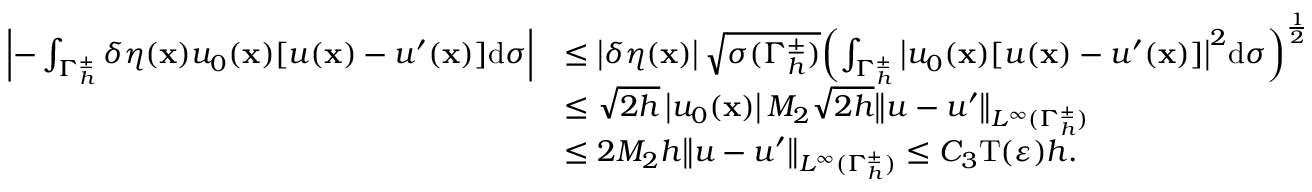<formula> <loc_0><loc_0><loc_500><loc_500>\begin{array} { r l } { \left | - \int _ { { \Gamma _ { h } ^ { \pm } } } \delta \eta ( \mathbf x ) { { u _ { 0 } } ( \mathbf x ) [ u ( \mathbf x ) - u ^ { \prime } ( \mathbf x ) ] } \mathrm d \sigma \right | } & { \leq \left | \delta \eta ( \mathbf x ) \right | \sqrt { \sigma ( { \Gamma _ { h } ^ { \pm } } ) } { \left ( \int _ { { \Gamma _ { h } ^ { \pm } } } { { { \left | { { u _ { 0 } } ( \mathbf x ) [ u ( \mathbf x ) - u ^ { \prime } ( \mathbf x ) ] } \right | } ^ { 2 } } } \mathrm d \sigma \right ) ^ { { \frac { 1 } { 2 } } } } } \\ & { \leq \sqrt { 2 h } \left | { { u _ { 0 } } ( \mathbf x ) } \right | M _ { 2 } \sqrt { 2 h } { \left \| { u - u ^ { \prime } } \right \| _ { { L ^ { \infty } } ( { \Gamma _ { h } ^ { \pm } } ) } } } \\ & { \leq 2 M _ { 2 } h { \left \| { u - u ^ { \prime } } \right \| _ { { L ^ { \infty } } ( { \Gamma _ { h } ^ { \pm } } ) } } \leq { C _ { 3 } } \mathrm T ( \varepsilon ) h . } \end{array}</formula> 